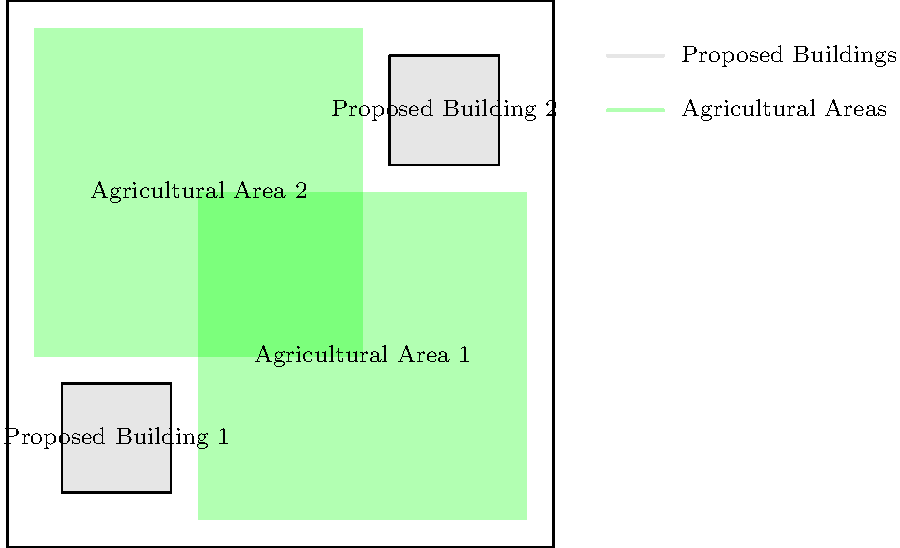Based on the site plan diagram, what percentage of the total land area is designated for agricultural use? To determine the percentage of land designated for agricultural use, we need to follow these steps:

1. Calculate the total area of the site:
   The site is a square with sides of 100 units.
   Total area = $100 \times 100 = 10,000$ square units

2. Calculate the area of Agricultural Area 1:
   Dimensions: $60 \times 60$ units
   Area 1 = $60 \times 60 = 3,600$ square units

3. Calculate the area of Agricultural Area 2:
   Dimensions: $60 \times 60$ units
   Area 2 = $60 \times 60 = 3,600$ square units

4. Calculate the total agricultural area:
   Total agricultural area = Area 1 + Area 2
   $3,600 + 3,600 = 7,200$ square units

5. Calculate the percentage of agricultural area:
   Percentage = (Agricultural area / Total area) × 100
   $$(7,200 / 10,000) \times 100 = 0.72 \times 100 = 72\%$$

Therefore, 72% of the total land area is designated for agricultural use.
Answer: 72% 